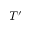Convert formula to latex. <formula><loc_0><loc_0><loc_500><loc_500>T ^ { \prime }</formula> 